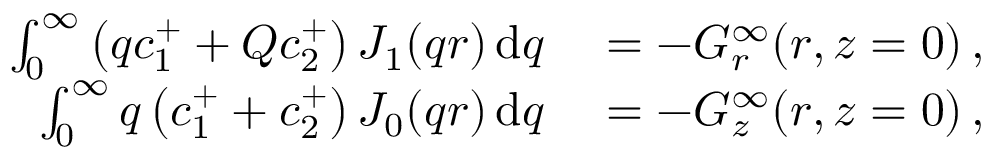Convert formula to latex. <formula><loc_0><loc_0><loc_500><loc_500>\begin{array} { r l } { \int _ { 0 } ^ { \infty } \left ( q c _ { 1 } ^ { + } + Q c _ { 2 } ^ { + } \right ) J _ { 1 } ( q r ) \, d q } & = - G _ { r } ^ { \infty } ( r , z = 0 ) \, , } \\ { \int _ { 0 } ^ { \infty } q \left ( c _ { 1 } ^ { + } + c _ { 2 } ^ { + } \right ) J _ { 0 } ( q r ) \, d q } & = - G _ { z } ^ { \infty } ( r , z = 0 ) \, , } \end{array}</formula> 